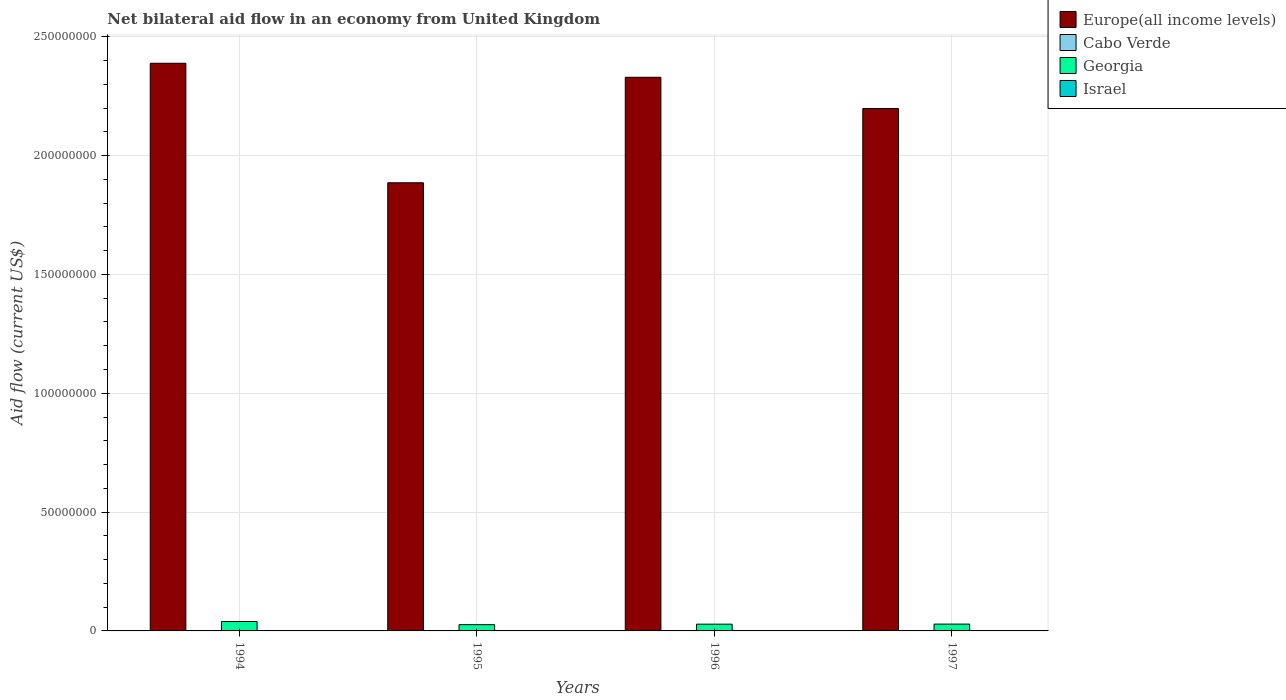Are the number of bars per tick equal to the number of legend labels?
Ensure brevity in your answer.  Yes. Are the number of bars on each tick of the X-axis equal?
Ensure brevity in your answer.  Yes. How many bars are there on the 1st tick from the right?
Make the answer very short. 4. What is the label of the 2nd group of bars from the left?
Provide a succinct answer. 1995. What is the net bilateral aid flow in Israel in 1997?
Keep it short and to the point. 2.00e+04. Across all years, what is the maximum net bilateral aid flow in Cabo Verde?
Provide a succinct answer. 1.50e+05. Across all years, what is the minimum net bilateral aid flow in Israel?
Offer a very short reply. 10000. In which year was the net bilateral aid flow in Georgia maximum?
Your answer should be compact. 1994. In which year was the net bilateral aid flow in Georgia minimum?
Provide a short and direct response. 1995. What is the total net bilateral aid flow in Cabo Verde in the graph?
Ensure brevity in your answer.  2.40e+05. What is the difference between the net bilateral aid flow in Israel in 1994 and that in 1997?
Offer a terse response. -10000. What is the difference between the net bilateral aid flow in Cabo Verde in 1996 and the net bilateral aid flow in Israel in 1994?
Give a very brief answer. 3.00e+04. What is the average net bilateral aid flow in Israel per year?
Provide a succinct answer. 1.50e+04. In the year 1995, what is the difference between the net bilateral aid flow in Europe(all income levels) and net bilateral aid flow in Georgia?
Your answer should be compact. 1.86e+08. What is the ratio of the net bilateral aid flow in Georgia in 1994 to that in 1997?
Provide a short and direct response. 1.38. What is the difference between the highest and the second highest net bilateral aid flow in Israel?
Your response must be concise. 0. Is the sum of the net bilateral aid flow in Georgia in 1995 and 1997 greater than the maximum net bilateral aid flow in Israel across all years?
Give a very brief answer. Yes. What does the 2nd bar from the left in 1994 represents?
Provide a short and direct response. Cabo Verde. Is it the case that in every year, the sum of the net bilateral aid flow in Georgia and net bilateral aid flow in Israel is greater than the net bilateral aid flow in Europe(all income levels)?
Offer a very short reply. No. Are all the bars in the graph horizontal?
Offer a terse response. No. Does the graph contain any zero values?
Give a very brief answer. No. Does the graph contain grids?
Provide a succinct answer. Yes. How are the legend labels stacked?
Provide a succinct answer. Vertical. What is the title of the graph?
Offer a terse response. Net bilateral aid flow in an economy from United Kingdom. Does "South Africa" appear as one of the legend labels in the graph?
Provide a short and direct response. No. What is the label or title of the Y-axis?
Your answer should be compact. Aid flow (current US$). What is the Aid flow (current US$) of Europe(all income levels) in 1994?
Offer a terse response. 2.39e+08. What is the Aid flow (current US$) in Georgia in 1994?
Give a very brief answer. 3.97e+06. What is the Aid flow (current US$) in Israel in 1994?
Offer a very short reply. 10000. What is the Aid flow (current US$) of Europe(all income levels) in 1995?
Keep it short and to the point. 1.89e+08. What is the Aid flow (current US$) of Cabo Verde in 1995?
Provide a short and direct response. 1.50e+05. What is the Aid flow (current US$) in Georgia in 1995?
Offer a terse response. 2.63e+06. What is the Aid flow (current US$) in Israel in 1995?
Your response must be concise. 2.00e+04. What is the Aid flow (current US$) in Europe(all income levels) in 1996?
Provide a succinct answer. 2.33e+08. What is the Aid flow (current US$) in Cabo Verde in 1996?
Offer a very short reply. 4.00e+04. What is the Aid flow (current US$) in Georgia in 1996?
Give a very brief answer. 2.84e+06. What is the Aid flow (current US$) of Israel in 1996?
Ensure brevity in your answer.  10000. What is the Aid flow (current US$) in Europe(all income levels) in 1997?
Offer a terse response. 2.20e+08. What is the Aid flow (current US$) of Georgia in 1997?
Offer a terse response. 2.87e+06. What is the Aid flow (current US$) of Israel in 1997?
Keep it short and to the point. 2.00e+04. Across all years, what is the maximum Aid flow (current US$) in Europe(all income levels)?
Keep it short and to the point. 2.39e+08. Across all years, what is the maximum Aid flow (current US$) of Georgia?
Make the answer very short. 3.97e+06. Across all years, what is the maximum Aid flow (current US$) of Israel?
Give a very brief answer. 2.00e+04. Across all years, what is the minimum Aid flow (current US$) of Europe(all income levels)?
Offer a very short reply. 1.89e+08. Across all years, what is the minimum Aid flow (current US$) of Cabo Verde?
Offer a terse response. 10000. Across all years, what is the minimum Aid flow (current US$) in Georgia?
Ensure brevity in your answer.  2.63e+06. Across all years, what is the minimum Aid flow (current US$) of Israel?
Give a very brief answer. 10000. What is the total Aid flow (current US$) in Europe(all income levels) in the graph?
Offer a terse response. 8.80e+08. What is the total Aid flow (current US$) in Georgia in the graph?
Give a very brief answer. 1.23e+07. What is the total Aid flow (current US$) of Israel in the graph?
Your answer should be compact. 6.00e+04. What is the difference between the Aid flow (current US$) of Europe(all income levels) in 1994 and that in 1995?
Offer a terse response. 5.03e+07. What is the difference between the Aid flow (current US$) in Cabo Verde in 1994 and that in 1995?
Your answer should be compact. -1.40e+05. What is the difference between the Aid flow (current US$) in Georgia in 1994 and that in 1995?
Your answer should be very brief. 1.34e+06. What is the difference between the Aid flow (current US$) of Europe(all income levels) in 1994 and that in 1996?
Give a very brief answer. 5.90e+06. What is the difference between the Aid flow (current US$) of Cabo Verde in 1994 and that in 1996?
Your answer should be very brief. -3.00e+04. What is the difference between the Aid flow (current US$) of Georgia in 1994 and that in 1996?
Keep it short and to the point. 1.13e+06. What is the difference between the Aid flow (current US$) in Israel in 1994 and that in 1996?
Give a very brief answer. 0. What is the difference between the Aid flow (current US$) of Europe(all income levels) in 1994 and that in 1997?
Keep it short and to the point. 1.90e+07. What is the difference between the Aid flow (current US$) of Cabo Verde in 1994 and that in 1997?
Offer a terse response. -3.00e+04. What is the difference between the Aid flow (current US$) of Georgia in 1994 and that in 1997?
Provide a succinct answer. 1.10e+06. What is the difference between the Aid flow (current US$) in Europe(all income levels) in 1995 and that in 1996?
Make the answer very short. -4.44e+07. What is the difference between the Aid flow (current US$) of Europe(all income levels) in 1995 and that in 1997?
Make the answer very short. -3.12e+07. What is the difference between the Aid flow (current US$) in Cabo Verde in 1995 and that in 1997?
Offer a terse response. 1.10e+05. What is the difference between the Aid flow (current US$) of Europe(all income levels) in 1996 and that in 1997?
Offer a very short reply. 1.31e+07. What is the difference between the Aid flow (current US$) of Georgia in 1996 and that in 1997?
Provide a short and direct response. -3.00e+04. What is the difference between the Aid flow (current US$) in Europe(all income levels) in 1994 and the Aid flow (current US$) in Cabo Verde in 1995?
Give a very brief answer. 2.39e+08. What is the difference between the Aid flow (current US$) of Europe(all income levels) in 1994 and the Aid flow (current US$) of Georgia in 1995?
Your answer should be very brief. 2.36e+08. What is the difference between the Aid flow (current US$) of Europe(all income levels) in 1994 and the Aid flow (current US$) of Israel in 1995?
Ensure brevity in your answer.  2.39e+08. What is the difference between the Aid flow (current US$) in Cabo Verde in 1994 and the Aid flow (current US$) in Georgia in 1995?
Give a very brief answer. -2.62e+06. What is the difference between the Aid flow (current US$) in Georgia in 1994 and the Aid flow (current US$) in Israel in 1995?
Your answer should be compact. 3.95e+06. What is the difference between the Aid flow (current US$) of Europe(all income levels) in 1994 and the Aid flow (current US$) of Cabo Verde in 1996?
Your response must be concise. 2.39e+08. What is the difference between the Aid flow (current US$) of Europe(all income levels) in 1994 and the Aid flow (current US$) of Georgia in 1996?
Your answer should be very brief. 2.36e+08. What is the difference between the Aid flow (current US$) in Europe(all income levels) in 1994 and the Aid flow (current US$) in Israel in 1996?
Give a very brief answer. 2.39e+08. What is the difference between the Aid flow (current US$) of Cabo Verde in 1994 and the Aid flow (current US$) of Georgia in 1996?
Your answer should be very brief. -2.83e+06. What is the difference between the Aid flow (current US$) of Georgia in 1994 and the Aid flow (current US$) of Israel in 1996?
Offer a terse response. 3.96e+06. What is the difference between the Aid flow (current US$) in Europe(all income levels) in 1994 and the Aid flow (current US$) in Cabo Verde in 1997?
Provide a short and direct response. 2.39e+08. What is the difference between the Aid flow (current US$) of Europe(all income levels) in 1994 and the Aid flow (current US$) of Georgia in 1997?
Give a very brief answer. 2.36e+08. What is the difference between the Aid flow (current US$) of Europe(all income levels) in 1994 and the Aid flow (current US$) of Israel in 1997?
Offer a very short reply. 2.39e+08. What is the difference between the Aid flow (current US$) in Cabo Verde in 1994 and the Aid flow (current US$) in Georgia in 1997?
Ensure brevity in your answer.  -2.86e+06. What is the difference between the Aid flow (current US$) of Cabo Verde in 1994 and the Aid flow (current US$) of Israel in 1997?
Ensure brevity in your answer.  -10000. What is the difference between the Aid flow (current US$) of Georgia in 1994 and the Aid flow (current US$) of Israel in 1997?
Ensure brevity in your answer.  3.95e+06. What is the difference between the Aid flow (current US$) in Europe(all income levels) in 1995 and the Aid flow (current US$) in Cabo Verde in 1996?
Offer a terse response. 1.89e+08. What is the difference between the Aid flow (current US$) of Europe(all income levels) in 1995 and the Aid flow (current US$) of Georgia in 1996?
Make the answer very short. 1.86e+08. What is the difference between the Aid flow (current US$) of Europe(all income levels) in 1995 and the Aid flow (current US$) of Israel in 1996?
Make the answer very short. 1.89e+08. What is the difference between the Aid flow (current US$) of Cabo Verde in 1995 and the Aid flow (current US$) of Georgia in 1996?
Offer a terse response. -2.69e+06. What is the difference between the Aid flow (current US$) in Georgia in 1995 and the Aid flow (current US$) in Israel in 1996?
Your answer should be compact. 2.62e+06. What is the difference between the Aid flow (current US$) in Europe(all income levels) in 1995 and the Aid flow (current US$) in Cabo Verde in 1997?
Offer a terse response. 1.89e+08. What is the difference between the Aid flow (current US$) of Europe(all income levels) in 1995 and the Aid flow (current US$) of Georgia in 1997?
Offer a terse response. 1.86e+08. What is the difference between the Aid flow (current US$) in Europe(all income levels) in 1995 and the Aid flow (current US$) in Israel in 1997?
Provide a succinct answer. 1.89e+08. What is the difference between the Aid flow (current US$) in Cabo Verde in 1995 and the Aid flow (current US$) in Georgia in 1997?
Make the answer very short. -2.72e+06. What is the difference between the Aid flow (current US$) of Georgia in 1995 and the Aid flow (current US$) of Israel in 1997?
Keep it short and to the point. 2.61e+06. What is the difference between the Aid flow (current US$) of Europe(all income levels) in 1996 and the Aid flow (current US$) of Cabo Verde in 1997?
Ensure brevity in your answer.  2.33e+08. What is the difference between the Aid flow (current US$) of Europe(all income levels) in 1996 and the Aid flow (current US$) of Georgia in 1997?
Keep it short and to the point. 2.30e+08. What is the difference between the Aid flow (current US$) of Europe(all income levels) in 1996 and the Aid flow (current US$) of Israel in 1997?
Provide a short and direct response. 2.33e+08. What is the difference between the Aid flow (current US$) in Cabo Verde in 1996 and the Aid flow (current US$) in Georgia in 1997?
Ensure brevity in your answer.  -2.83e+06. What is the difference between the Aid flow (current US$) of Georgia in 1996 and the Aid flow (current US$) of Israel in 1997?
Your response must be concise. 2.82e+06. What is the average Aid flow (current US$) of Europe(all income levels) per year?
Provide a short and direct response. 2.20e+08. What is the average Aid flow (current US$) of Cabo Verde per year?
Give a very brief answer. 6.00e+04. What is the average Aid flow (current US$) in Georgia per year?
Keep it short and to the point. 3.08e+06. What is the average Aid flow (current US$) in Israel per year?
Offer a terse response. 1.50e+04. In the year 1994, what is the difference between the Aid flow (current US$) of Europe(all income levels) and Aid flow (current US$) of Cabo Verde?
Provide a succinct answer. 2.39e+08. In the year 1994, what is the difference between the Aid flow (current US$) of Europe(all income levels) and Aid flow (current US$) of Georgia?
Provide a succinct answer. 2.35e+08. In the year 1994, what is the difference between the Aid flow (current US$) of Europe(all income levels) and Aid flow (current US$) of Israel?
Provide a succinct answer. 2.39e+08. In the year 1994, what is the difference between the Aid flow (current US$) of Cabo Verde and Aid flow (current US$) of Georgia?
Offer a very short reply. -3.96e+06. In the year 1994, what is the difference between the Aid flow (current US$) of Georgia and Aid flow (current US$) of Israel?
Provide a short and direct response. 3.96e+06. In the year 1995, what is the difference between the Aid flow (current US$) in Europe(all income levels) and Aid flow (current US$) in Cabo Verde?
Give a very brief answer. 1.88e+08. In the year 1995, what is the difference between the Aid flow (current US$) of Europe(all income levels) and Aid flow (current US$) of Georgia?
Provide a succinct answer. 1.86e+08. In the year 1995, what is the difference between the Aid flow (current US$) of Europe(all income levels) and Aid flow (current US$) of Israel?
Ensure brevity in your answer.  1.89e+08. In the year 1995, what is the difference between the Aid flow (current US$) in Cabo Verde and Aid flow (current US$) in Georgia?
Provide a short and direct response. -2.48e+06. In the year 1995, what is the difference between the Aid flow (current US$) in Cabo Verde and Aid flow (current US$) in Israel?
Keep it short and to the point. 1.30e+05. In the year 1995, what is the difference between the Aid flow (current US$) in Georgia and Aid flow (current US$) in Israel?
Ensure brevity in your answer.  2.61e+06. In the year 1996, what is the difference between the Aid flow (current US$) of Europe(all income levels) and Aid flow (current US$) of Cabo Verde?
Your answer should be very brief. 2.33e+08. In the year 1996, what is the difference between the Aid flow (current US$) of Europe(all income levels) and Aid flow (current US$) of Georgia?
Make the answer very short. 2.30e+08. In the year 1996, what is the difference between the Aid flow (current US$) of Europe(all income levels) and Aid flow (current US$) of Israel?
Your answer should be compact. 2.33e+08. In the year 1996, what is the difference between the Aid flow (current US$) in Cabo Verde and Aid flow (current US$) in Georgia?
Provide a short and direct response. -2.80e+06. In the year 1996, what is the difference between the Aid flow (current US$) of Cabo Verde and Aid flow (current US$) of Israel?
Offer a terse response. 3.00e+04. In the year 1996, what is the difference between the Aid flow (current US$) in Georgia and Aid flow (current US$) in Israel?
Your response must be concise. 2.83e+06. In the year 1997, what is the difference between the Aid flow (current US$) of Europe(all income levels) and Aid flow (current US$) of Cabo Verde?
Keep it short and to the point. 2.20e+08. In the year 1997, what is the difference between the Aid flow (current US$) in Europe(all income levels) and Aid flow (current US$) in Georgia?
Give a very brief answer. 2.17e+08. In the year 1997, what is the difference between the Aid flow (current US$) of Europe(all income levels) and Aid flow (current US$) of Israel?
Make the answer very short. 2.20e+08. In the year 1997, what is the difference between the Aid flow (current US$) in Cabo Verde and Aid flow (current US$) in Georgia?
Give a very brief answer. -2.83e+06. In the year 1997, what is the difference between the Aid flow (current US$) of Georgia and Aid flow (current US$) of Israel?
Keep it short and to the point. 2.85e+06. What is the ratio of the Aid flow (current US$) of Europe(all income levels) in 1994 to that in 1995?
Make the answer very short. 1.27. What is the ratio of the Aid flow (current US$) in Cabo Verde in 1994 to that in 1995?
Ensure brevity in your answer.  0.07. What is the ratio of the Aid flow (current US$) of Georgia in 1994 to that in 1995?
Offer a terse response. 1.51. What is the ratio of the Aid flow (current US$) of Europe(all income levels) in 1994 to that in 1996?
Ensure brevity in your answer.  1.03. What is the ratio of the Aid flow (current US$) of Georgia in 1994 to that in 1996?
Make the answer very short. 1.4. What is the ratio of the Aid flow (current US$) of Europe(all income levels) in 1994 to that in 1997?
Offer a very short reply. 1.09. What is the ratio of the Aid flow (current US$) in Georgia in 1994 to that in 1997?
Provide a succinct answer. 1.38. What is the ratio of the Aid flow (current US$) in Israel in 1994 to that in 1997?
Your answer should be very brief. 0.5. What is the ratio of the Aid flow (current US$) of Europe(all income levels) in 1995 to that in 1996?
Offer a terse response. 0.81. What is the ratio of the Aid flow (current US$) in Cabo Verde in 1995 to that in 1996?
Provide a succinct answer. 3.75. What is the ratio of the Aid flow (current US$) in Georgia in 1995 to that in 1996?
Provide a short and direct response. 0.93. What is the ratio of the Aid flow (current US$) of Israel in 1995 to that in 1996?
Offer a very short reply. 2. What is the ratio of the Aid flow (current US$) in Europe(all income levels) in 1995 to that in 1997?
Your response must be concise. 0.86. What is the ratio of the Aid flow (current US$) of Cabo Verde in 1995 to that in 1997?
Your response must be concise. 3.75. What is the ratio of the Aid flow (current US$) of Georgia in 1995 to that in 1997?
Your answer should be compact. 0.92. What is the ratio of the Aid flow (current US$) in Europe(all income levels) in 1996 to that in 1997?
Your answer should be compact. 1.06. What is the ratio of the Aid flow (current US$) in Georgia in 1996 to that in 1997?
Offer a very short reply. 0.99. What is the ratio of the Aid flow (current US$) in Israel in 1996 to that in 1997?
Your answer should be compact. 0.5. What is the difference between the highest and the second highest Aid flow (current US$) of Europe(all income levels)?
Provide a short and direct response. 5.90e+06. What is the difference between the highest and the second highest Aid flow (current US$) of Georgia?
Provide a succinct answer. 1.10e+06. What is the difference between the highest and the lowest Aid flow (current US$) in Europe(all income levels)?
Provide a succinct answer. 5.03e+07. What is the difference between the highest and the lowest Aid flow (current US$) of Georgia?
Give a very brief answer. 1.34e+06. What is the difference between the highest and the lowest Aid flow (current US$) of Israel?
Give a very brief answer. 10000. 